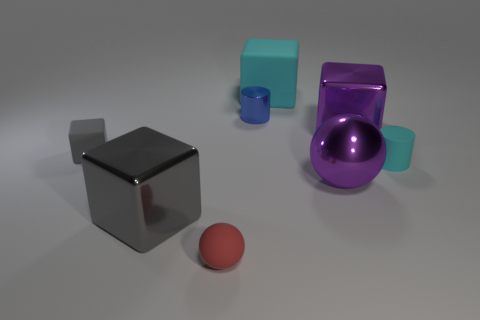Is there any other thing that has the same color as the big metallic ball?
Your response must be concise. Yes. What is the shape of the other matte thing that is the same color as the big matte object?
Ensure brevity in your answer.  Cylinder. There is a metallic object on the left side of the tiny red thing; what is its size?
Provide a short and direct response. Large. There is a cyan rubber object that is the same size as the rubber sphere; what is its shape?
Your response must be concise. Cylinder. Is the large object that is on the left side of the tiny red sphere made of the same material as the big sphere that is in front of the small metallic object?
Give a very brief answer. Yes. What material is the object that is left of the large cube that is to the left of the tiny red ball made of?
Your response must be concise. Rubber. There is a purple shiny object that is in front of the rubber cube that is on the left side of the blue cylinder on the right side of the small gray matte thing; how big is it?
Keep it short and to the point. Large. Do the rubber sphere and the purple ball have the same size?
Provide a short and direct response. No. There is a gray thing right of the tiny block; does it have the same shape as the cyan matte object in front of the shiny cylinder?
Your answer should be compact. No. Are there any large purple blocks behind the tiny object to the right of the purple metal sphere?
Ensure brevity in your answer.  Yes. 